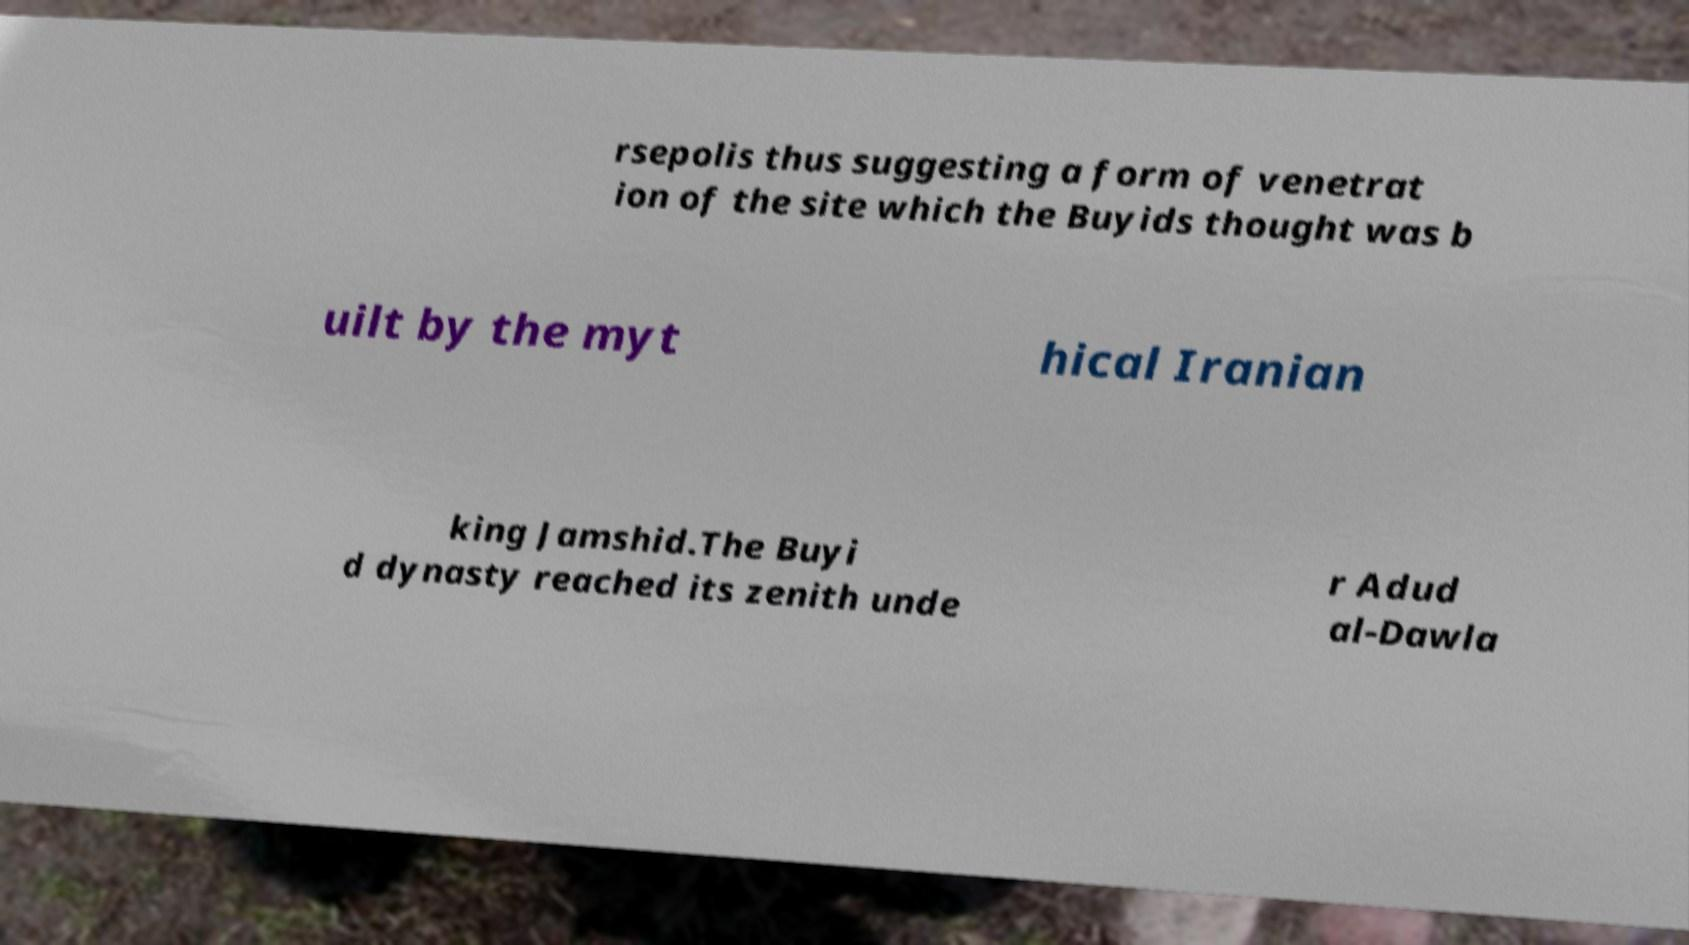What messages or text are displayed in this image? I need them in a readable, typed format. rsepolis thus suggesting a form of venetrat ion of the site which the Buyids thought was b uilt by the myt hical Iranian king Jamshid.The Buyi d dynasty reached its zenith unde r Adud al-Dawla 